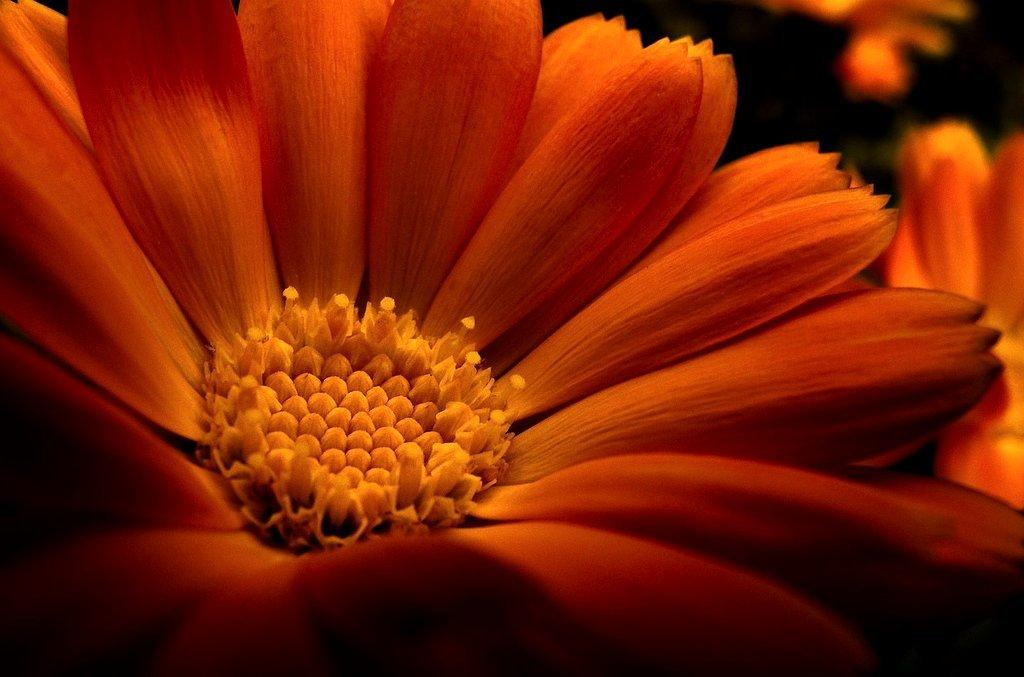What type of plant is visible in the image? There is a flower with petals in the image. Are there any other flowers in the image besides the one with petals? Yes, there are other flowers beside the flower with petals in the image. What color are the eyes of the dad in the image? There is no dad or eyes present in the image; it only features flowers. 